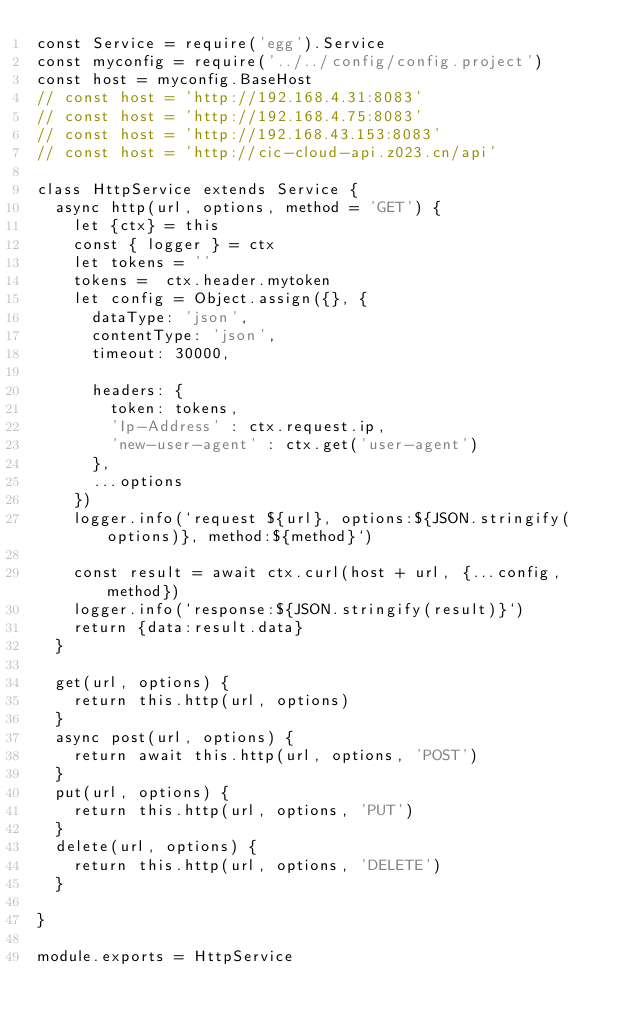<code> <loc_0><loc_0><loc_500><loc_500><_JavaScript_>const Service = require('egg').Service
const myconfig = require('../../config/config.project')
const host = myconfig.BaseHost
// const host = 'http://192.168.4.31:8083'
// const host = 'http://192.168.4.75:8083'
// const host = 'http://192.168.43.153:8083'
// const host = 'http://cic-cloud-api.z023.cn/api'

class HttpService extends Service {
  async http(url, options, method = 'GET') {
    let {ctx} = this
    const { logger } = ctx
    let tokens = ''
    tokens =  ctx.header.mytoken
    let config = Object.assign({}, {
      dataType: 'json',
      contentType: 'json',
      timeout: 30000,

      headers: {
        token: tokens,
        'Ip-Address' : ctx.request.ip,
        'new-user-agent' : ctx.get('user-agent')
      },
      ...options
    })
    logger.info(`request ${url}, options:${JSON.stringify(options)}, method:${method}`)

    const result = await ctx.curl(host + url, {...config, method})
    logger.info(`response:${JSON.stringify(result)}`)
    return {data:result.data}
  }

  get(url, options) {
    return this.http(url, options)
  }
  async post(url, options) {
    return await this.http(url, options, 'POST')
  }
  put(url, options) {
    return this.http(url, options, 'PUT')
  }
  delete(url, options) {
    return this.http(url, options, 'DELETE')
  }

}

module.exports = HttpService
</code> 